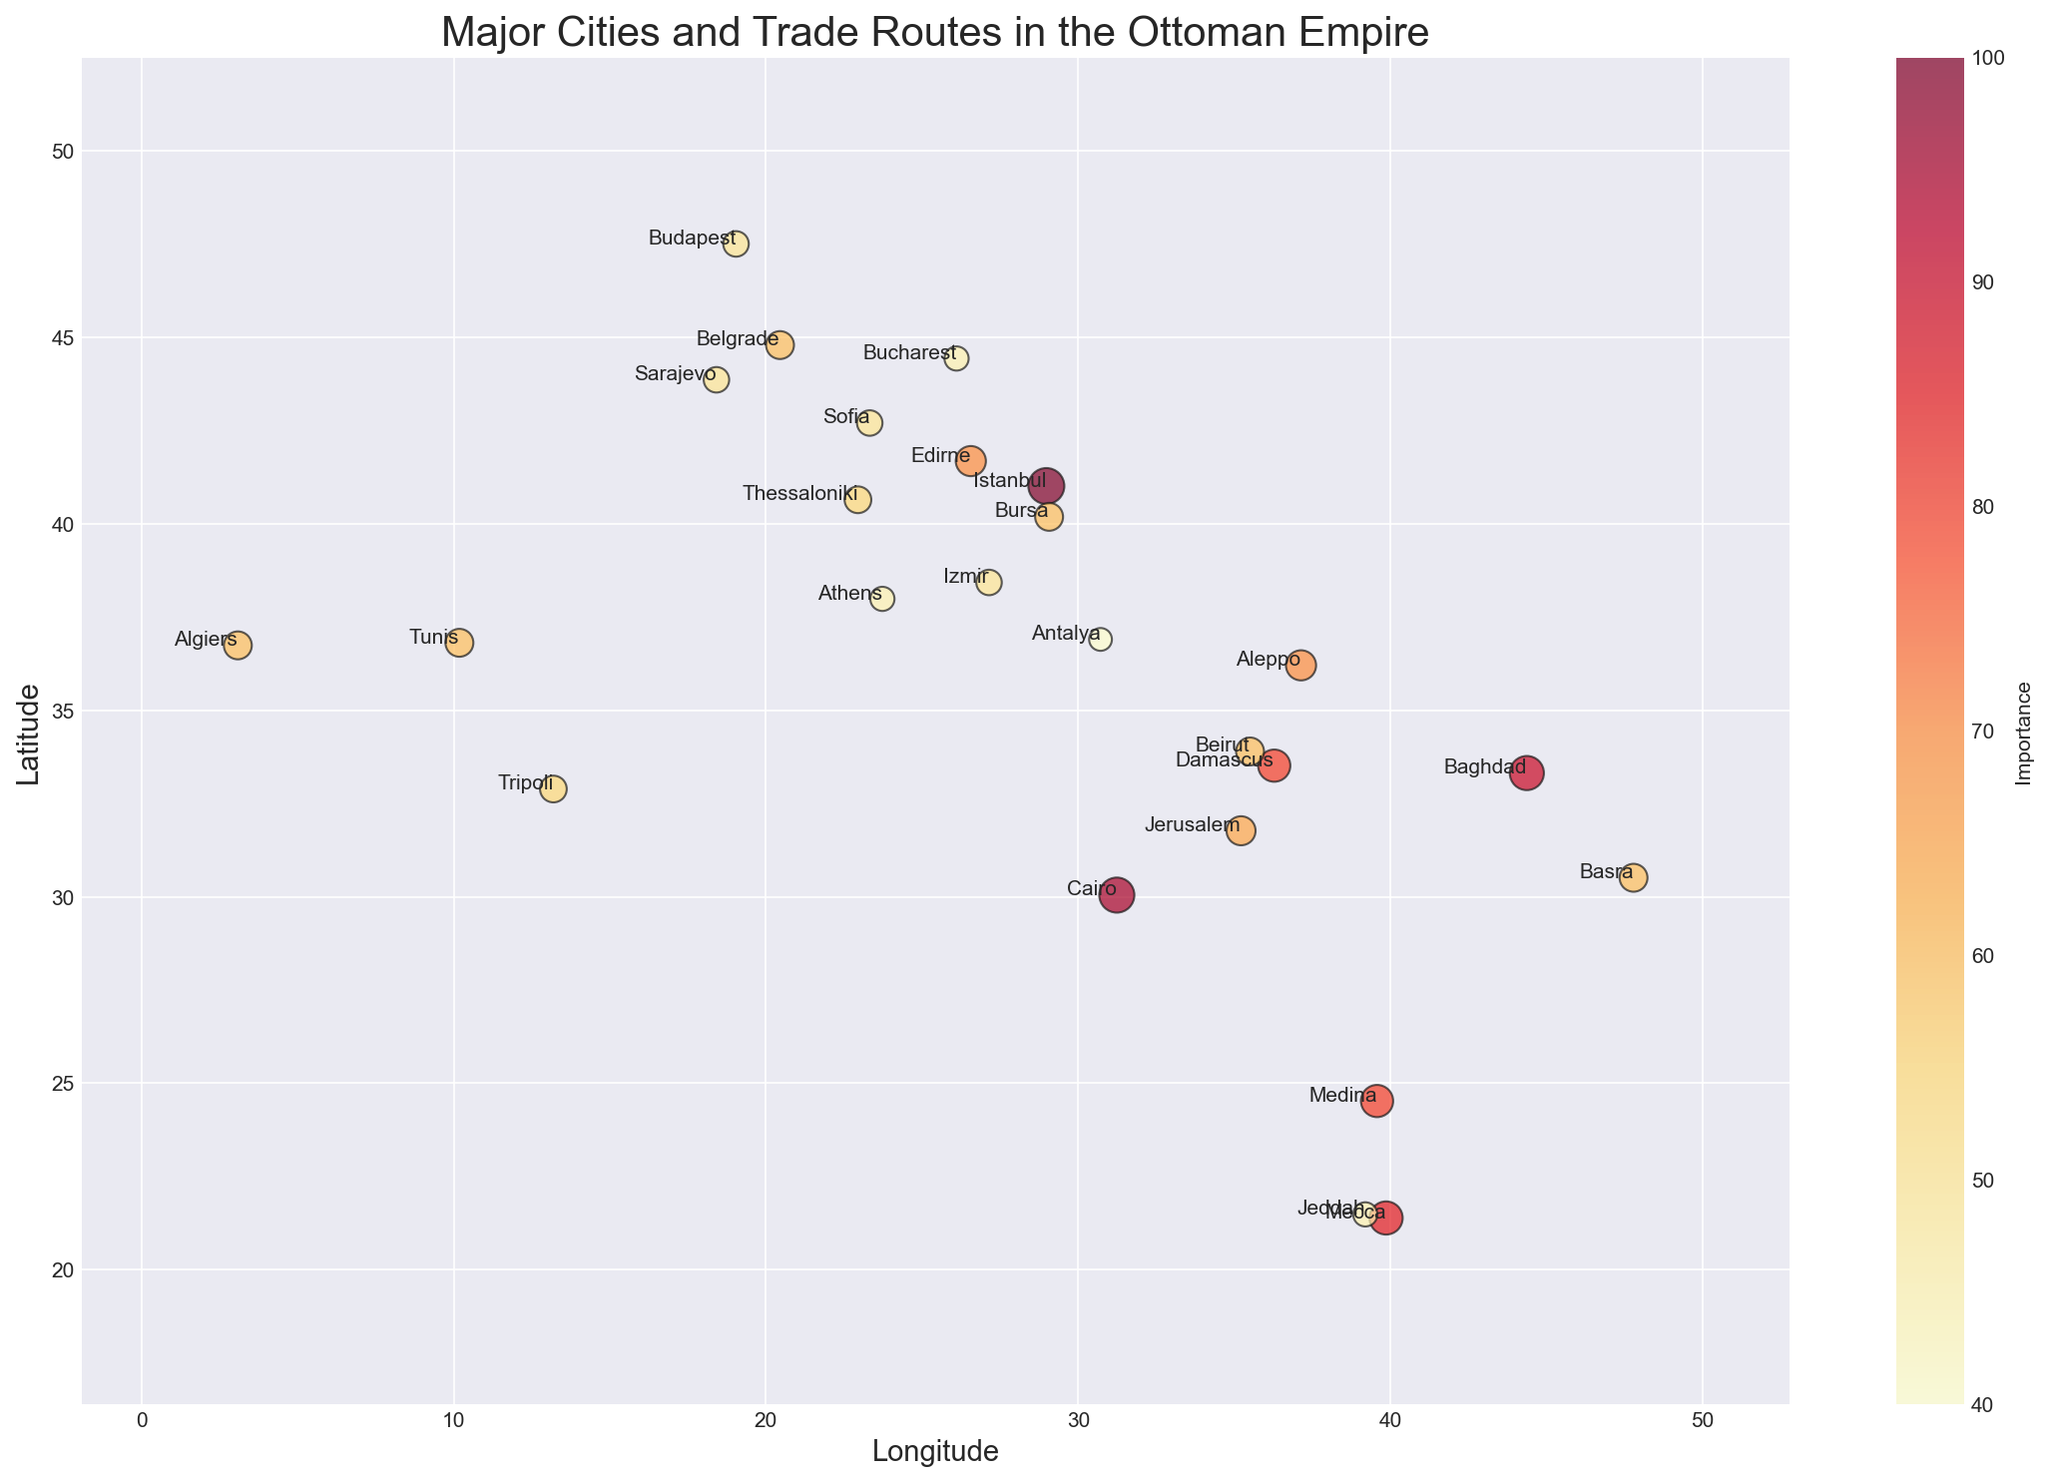What's the southernmost city on the map? The southernmost city is the one with the lowest latitude value. From the data, Mecca has the lowest latitude (21.3891).
Answer: Mecca Which city has the highest importance value? The importance value is represented by colors and the size of the dots. The city with the largest importance value is Istanbul (value = 100).
Answer: Istanbul Compare the importance of Cairo and Alexandria. Which is higher and by how much? Cairo has an importance value of 95, and Bursa (near Alexandria) has an importance value of 60. Cairo's importance is higher by 35.
Answer: Cairo by 35 Out of Damascus, Baghdad, and Istanbul, which city is located furthest east? Baghdad has the highest longitude value among the three. Longitude: Baghdad (44.3661), Damascus (36.2765), Istanbul (28.9784).
Answer: Baghdad Calculate the average importance value of the cities in the map. Sum the importance values of all cities and divide by the number of cities: (100 + 70 + 60 + 50 + 40 + 80 + 70 + 90 + 95 + 85 + 80 + 55 + 60 + 60 + 50 + 60 + 55 + 45 + 50 + 45 + 50 + 65 + 60 + 45 + 60) / 25 = 66.
Answer: 66 What is the difference in latitude between the northernmost and southernmost cities on the map? The northernmost city is Budapest (latitude = 47.4979) and the southernmost is Mecca (latitude = 21.3891). The difference is 47.4979 - 21.3891 = 26.1088.
Answer: 26.1088 Which city is located closer to Istanbul, Thessaloniki or Baghdad? Compare the distances by comparing their longitudes and latitudes. Thessaloniki (latitude = 40.6401, longitude = 22.9444) is closer to Istanbul (latitude = 41.0082, longitude = 28.9784) than Baghdad (latitude = 33.3152, longitude = 44.3661).
Answer: Thessaloniki Which two cities have the same importance value of 60? From the data, the cities with an importance value of 60 are Bursa, Tunis, Algiers, Belgrade, and Basra.
Answer: Bursa, Tunis, Algiers, Belgrade, and Basra What's the difference in importance between the cities with the highest and lowest values? The highest importance value is 100 (Istanbul) and the lowest is 40 (Antalya). The difference is 100 - 40 = 60.
Answer: 60 